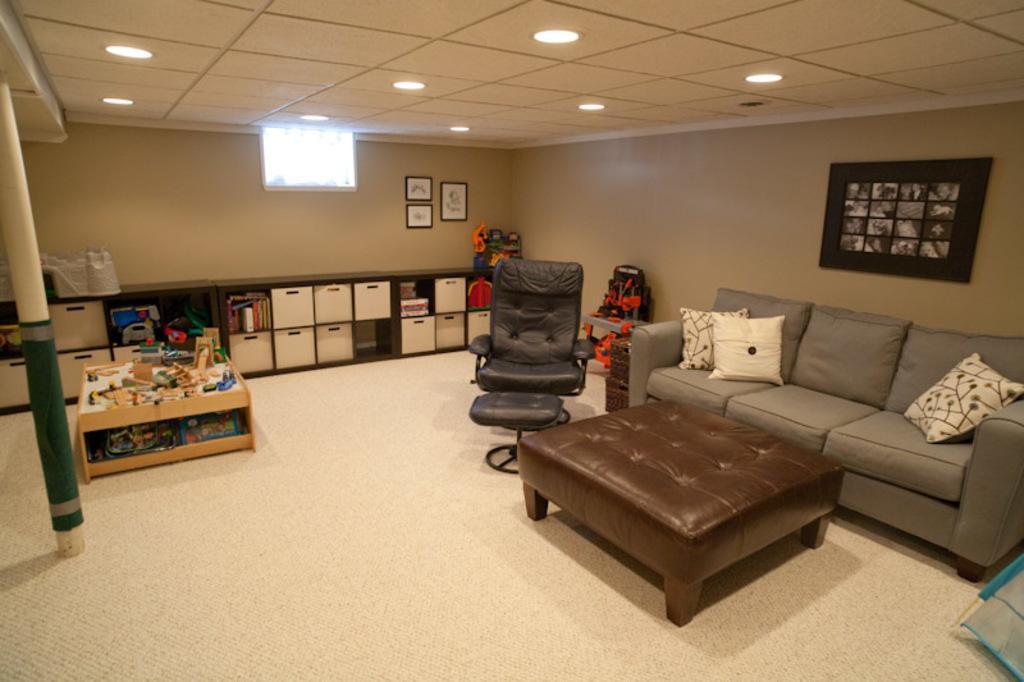Describe this image in one or two sentences. In this image I can see there is a sofa, a chair, table and some other objects on the floor. 